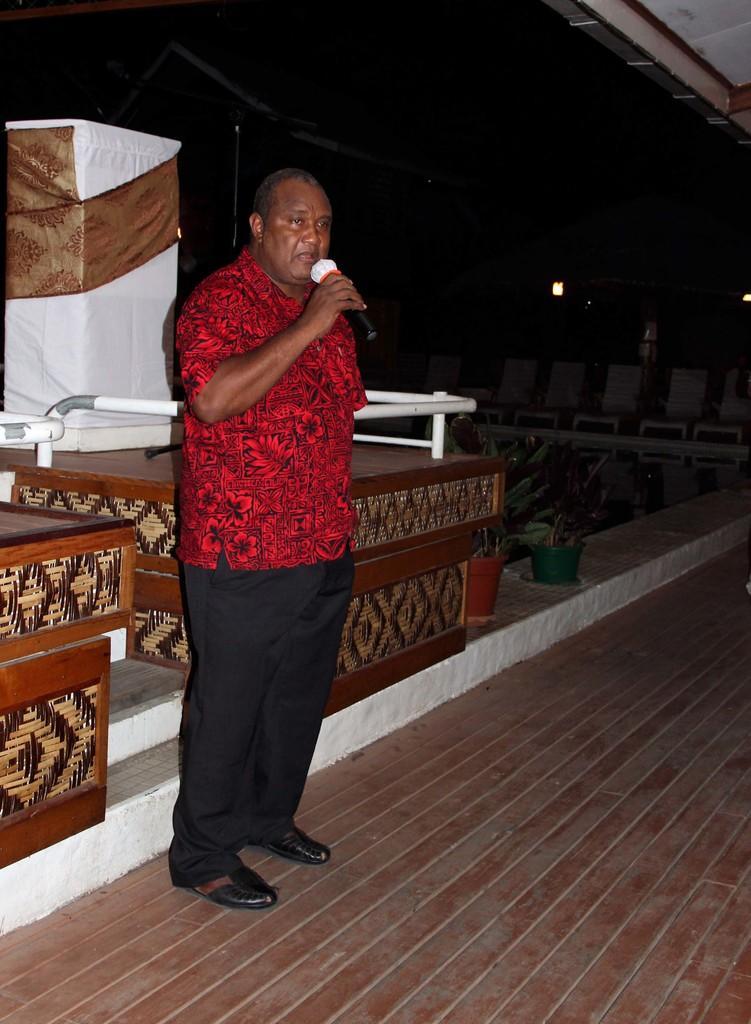Can you describe this image briefly? There is a man standing in the foreground area of the image, by holding a mic, it seems like a stage, plants and other objects in the background. 